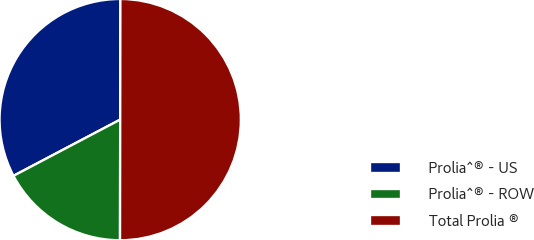Convert chart. <chart><loc_0><loc_0><loc_500><loc_500><pie_chart><fcel>Prolia^® - US<fcel>Prolia^® - ROW<fcel>Total Prolia ®<nl><fcel>32.74%<fcel>17.26%<fcel>50.0%<nl></chart> 